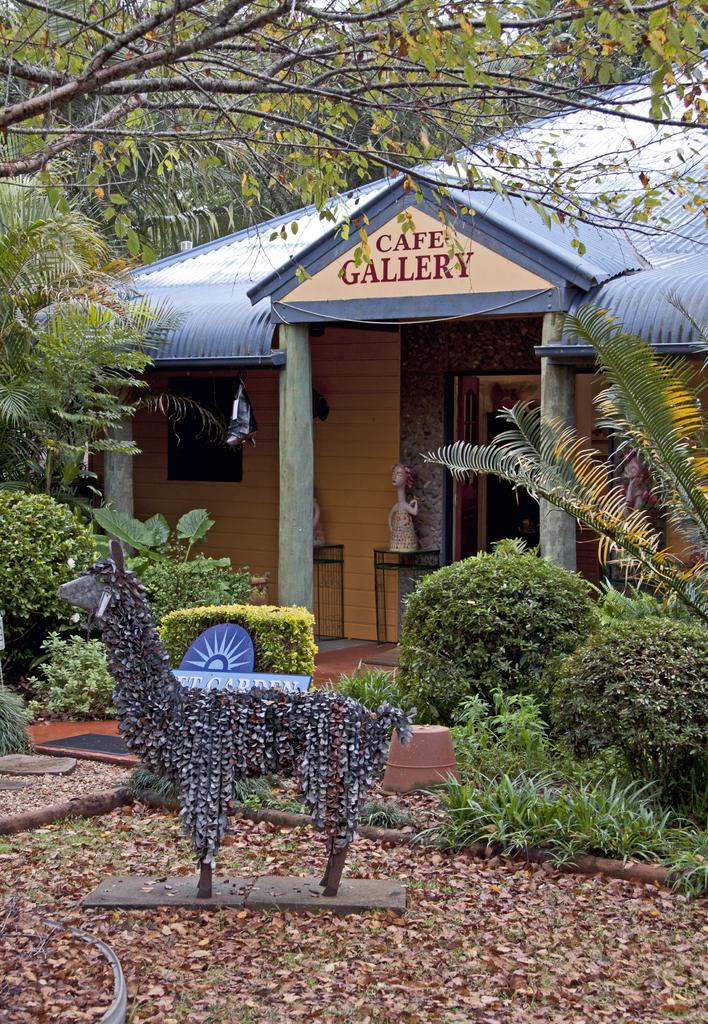What type of structure is visible in the image? There is a building in the image. What can be seen in the background of the image? There are trees and plants in the image. What is the purpose of the board with text in the image? The purpose of the board with text is not clear from the image, but it may be used for announcements or information. What is the statue in the image depicting? The image does not provide enough detail to determine what the statue is depicting. What text can be seen on the porch in the image? There is text on the porch in the image, but the specific words or message cannot be determined from the image. How do the manager and friends feel about the aftermath of the event in the image? There is no manager, friends, or event depicted in the image, so it is not possible to answer this question. 